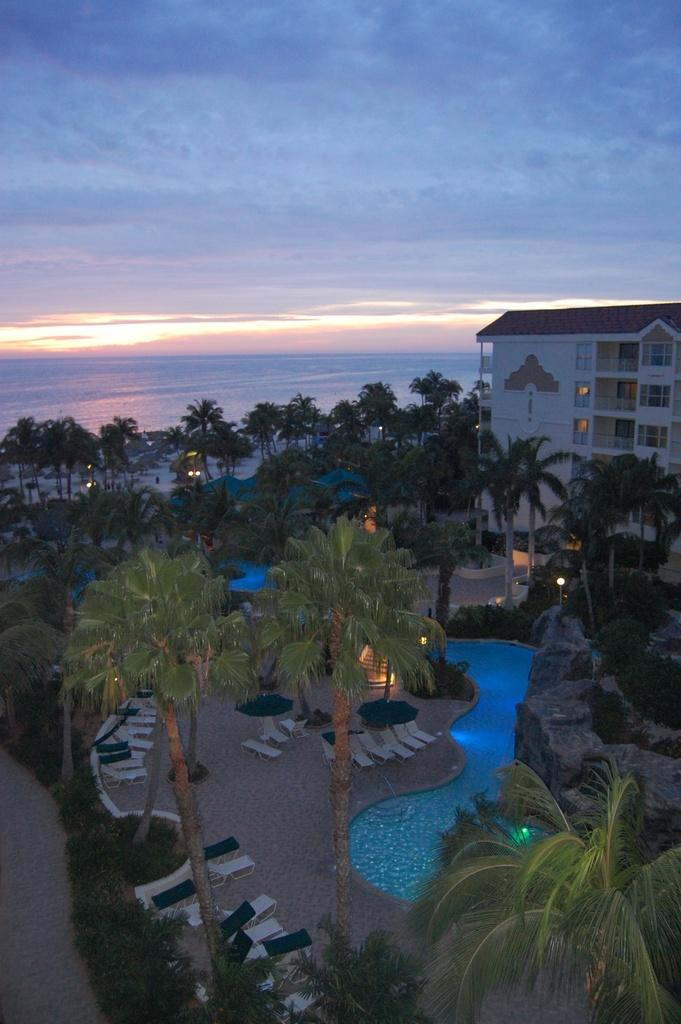What type of vegetation can be seen in the foreground of the image? There is grass, plants, and trees in the foreground of the image. What objects are present in the foreground of the image? There are beds and a swimming pool in the foreground of the image. What additional feature can be seen in the foreground of the image? There are lights in the foreground of the image. What can be seen in the background of the image? There is a building and the sky visible in the background of the image. What type of jail can be seen in the image? There is no jail present in the image. What boundary is visible in the image? There is no boundary visible in the image. 